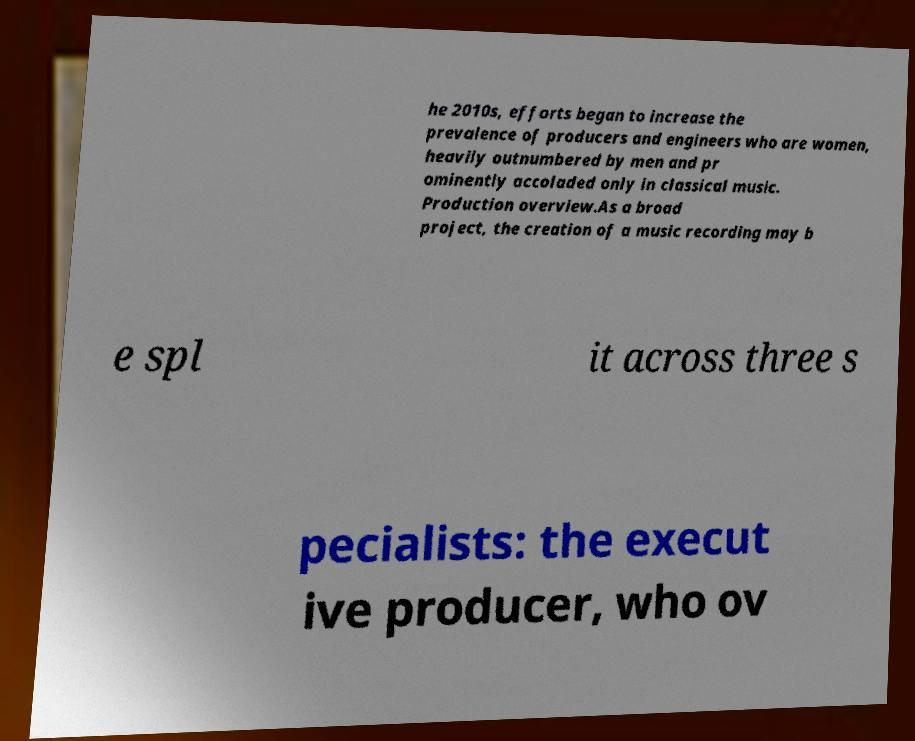Please identify and transcribe the text found in this image. he 2010s, efforts began to increase the prevalence of producers and engineers who are women, heavily outnumbered by men and pr ominently accoladed only in classical music. Production overview.As a broad project, the creation of a music recording may b e spl it across three s pecialists: the execut ive producer, who ov 